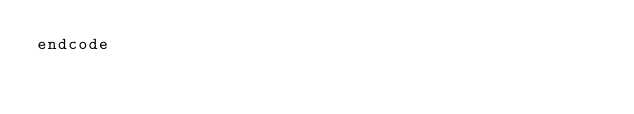Convert code to text. <code><loc_0><loc_0><loc_500><loc_500><_SQL_>endcode
</code> 